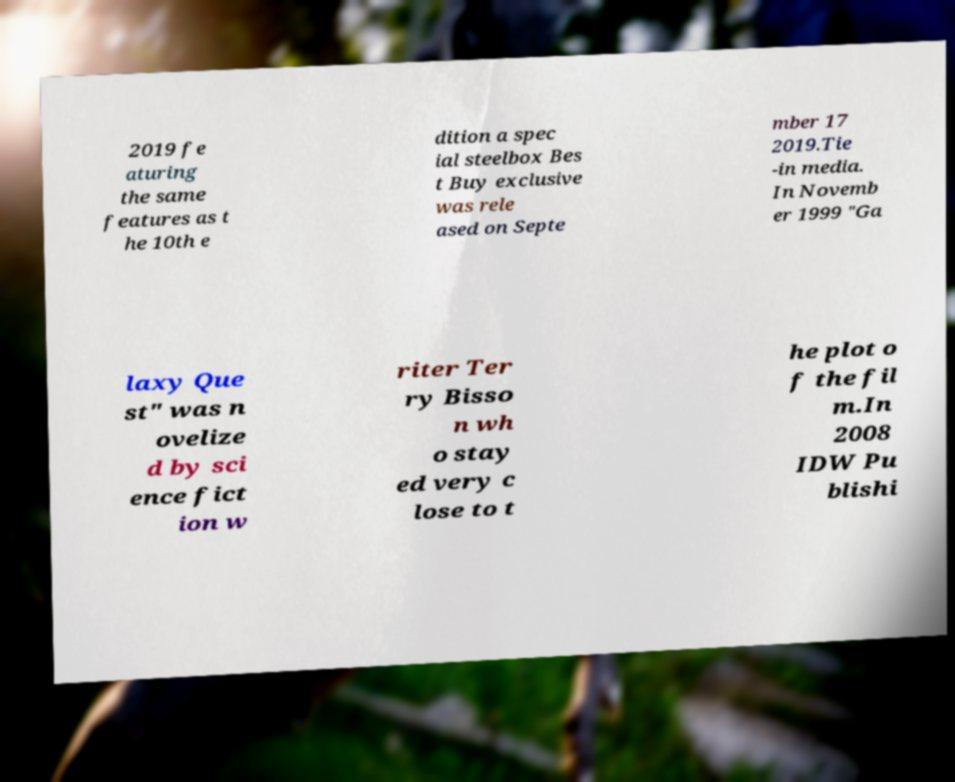There's text embedded in this image that I need extracted. Can you transcribe it verbatim? 2019 fe aturing the same features as t he 10th e dition a spec ial steelbox Bes t Buy exclusive was rele ased on Septe mber 17 2019.Tie -in media. In Novemb er 1999 "Ga laxy Que st" was n ovelize d by sci ence fict ion w riter Ter ry Bisso n wh o stay ed very c lose to t he plot o f the fil m.In 2008 IDW Pu blishi 